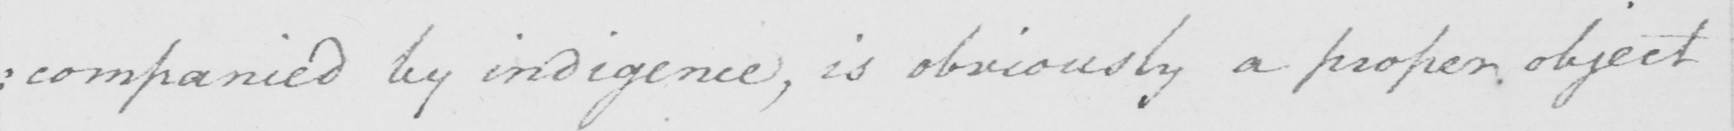Can you tell me what this handwritten text says? : companied by indigence , is obviously a proper object 